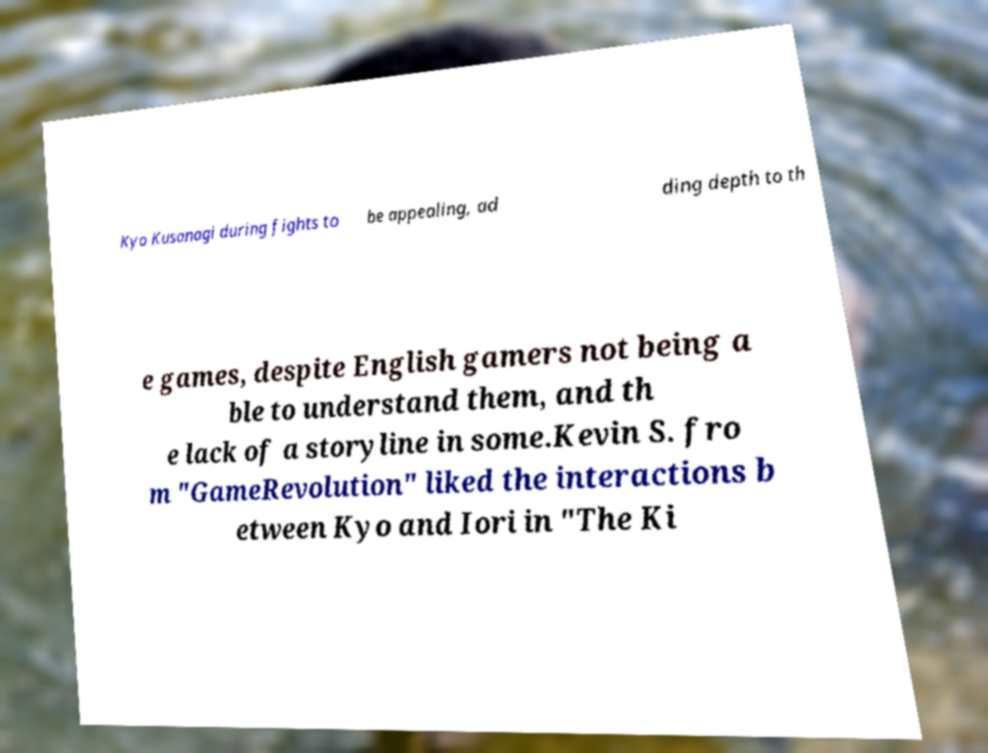Could you assist in decoding the text presented in this image and type it out clearly? Kyo Kusanagi during fights to be appealing, ad ding depth to th e games, despite English gamers not being a ble to understand them, and th e lack of a storyline in some.Kevin S. fro m "GameRevolution" liked the interactions b etween Kyo and Iori in "The Ki 